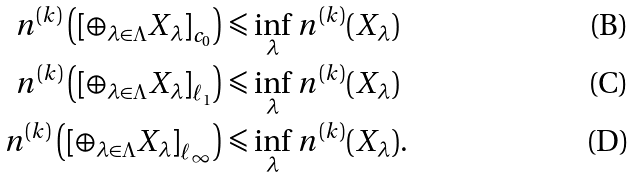<formula> <loc_0><loc_0><loc_500><loc_500>n ^ { ( k ) } \left ( \left [ \oplus _ { \lambda \in \Lambda } X _ { \lambda } \right ] _ { c _ { 0 } } \right ) & \leqslant \inf _ { \lambda } \, n ^ { ( k ) } ( X _ { \lambda } ) \\ n ^ { ( k ) } \left ( \left [ \oplus _ { \lambda \in \Lambda } X _ { \lambda } \right ] _ { \ell _ { 1 } } \right ) & \leqslant \inf _ { \lambda } \, n ^ { ( k ) } ( X _ { \lambda } ) \\ n ^ { ( k ) } \left ( \left [ \oplus _ { \lambda \in \Lambda } X _ { \lambda } \right ] _ { \ell _ { \infty } } \right ) & \leqslant \inf _ { \lambda } \, n ^ { ( k ) } ( X _ { \lambda } ) .</formula> 